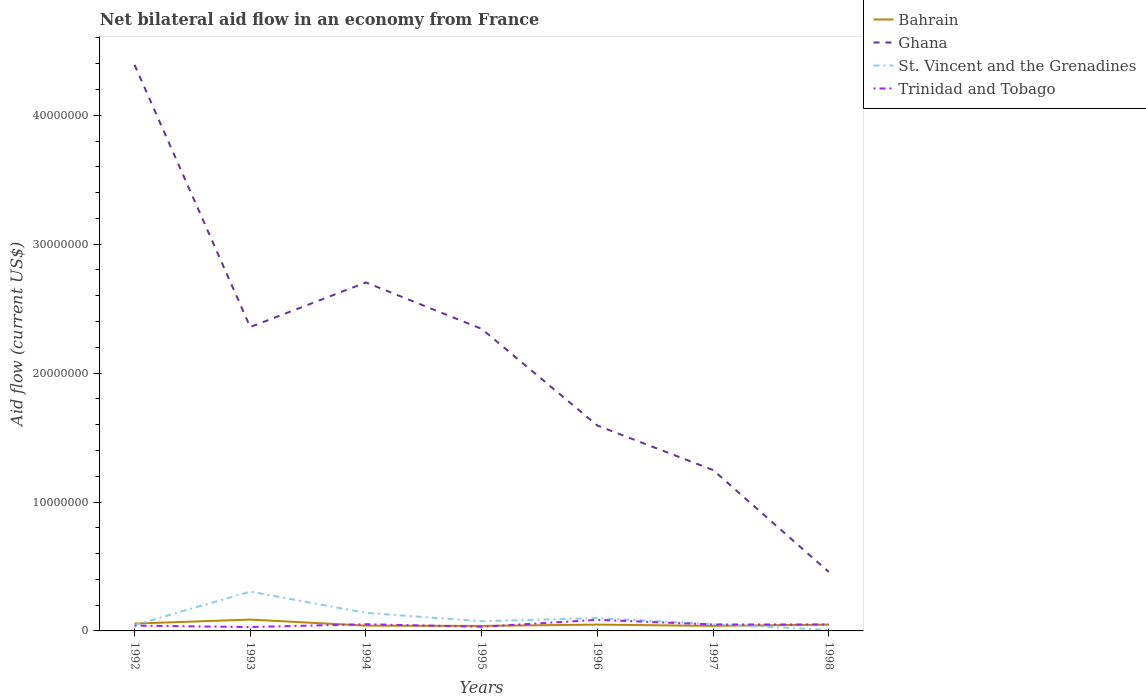How many different coloured lines are there?
Give a very brief answer. 4. Across all years, what is the maximum net bilateral aid flow in Ghana?
Keep it short and to the point. 4.57e+06. What is the total net bilateral aid flow in St. Vincent and the Grenadines in the graph?
Your answer should be compact. 9.20e+05. What is the difference between the highest and the second highest net bilateral aid flow in Trinidad and Tobago?
Your answer should be very brief. 5.60e+05. Is the net bilateral aid flow in St. Vincent and the Grenadines strictly greater than the net bilateral aid flow in Ghana over the years?
Provide a succinct answer. Yes. How many lines are there?
Provide a short and direct response. 4. How many years are there in the graph?
Your answer should be compact. 7. What is the difference between two consecutive major ticks on the Y-axis?
Keep it short and to the point. 1.00e+07. Are the values on the major ticks of Y-axis written in scientific E-notation?
Make the answer very short. No. Does the graph contain grids?
Give a very brief answer. No. Where does the legend appear in the graph?
Your response must be concise. Top right. What is the title of the graph?
Offer a very short reply. Net bilateral aid flow in an economy from France. Does "St. Vincent and the Grenadines" appear as one of the legend labels in the graph?
Your response must be concise. Yes. What is the Aid flow (current US$) of Bahrain in 1992?
Keep it short and to the point. 5.70e+05. What is the Aid flow (current US$) of Ghana in 1992?
Provide a short and direct response. 4.39e+07. What is the Aid flow (current US$) of Bahrain in 1993?
Give a very brief answer. 8.80e+05. What is the Aid flow (current US$) in Ghana in 1993?
Provide a short and direct response. 2.36e+07. What is the Aid flow (current US$) of St. Vincent and the Grenadines in 1993?
Your response must be concise. 3.05e+06. What is the Aid flow (current US$) of Trinidad and Tobago in 1993?
Ensure brevity in your answer.  3.00e+05. What is the Aid flow (current US$) of Bahrain in 1994?
Your response must be concise. 4.10e+05. What is the Aid flow (current US$) in Ghana in 1994?
Provide a short and direct response. 2.70e+07. What is the Aid flow (current US$) of St. Vincent and the Grenadines in 1994?
Keep it short and to the point. 1.40e+06. What is the Aid flow (current US$) in Trinidad and Tobago in 1994?
Your response must be concise. 5.20e+05. What is the Aid flow (current US$) of Ghana in 1995?
Ensure brevity in your answer.  2.34e+07. What is the Aid flow (current US$) in St. Vincent and the Grenadines in 1995?
Keep it short and to the point. 7.50e+05. What is the Aid flow (current US$) of Bahrain in 1996?
Give a very brief answer. 4.90e+05. What is the Aid flow (current US$) of Ghana in 1996?
Offer a very short reply. 1.59e+07. What is the Aid flow (current US$) in Trinidad and Tobago in 1996?
Ensure brevity in your answer.  8.60e+05. What is the Aid flow (current US$) in Bahrain in 1997?
Your response must be concise. 3.90e+05. What is the Aid flow (current US$) of Ghana in 1997?
Keep it short and to the point. 1.25e+07. What is the Aid flow (current US$) of St. Vincent and the Grenadines in 1997?
Offer a terse response. 5.20e+05. What is the Aid flow (current US$) in Bahrain in 1998?
Your response must be concise. 4.90e+05. What is the Aid flow (current US$) of Ghana in 1998?
Keep it short and to the point. 4.57e+06. What is the Aid flow (current US$) of St. Vincent and the Grenadines in 1998?
Your answer should be very brief. 8.00e+04. Across all years, what is the maximum Aid flow (current US$) in Bahrain?
Provide a succinct answer. 8.80e+05. Across all years, what is the maximum Aid flow (current US$) of Ghana?
Give a very brief answer. 4.39e+07. Across all years, what is the maximum Aid flow (current US$) in St. Vincent and the Grenadines?
Give a very brief answer. 3.05e+06. Across all years, what is the maximum Aid flow (current US$) of Trinidad and Tobago?
Ensure brevity in your answer.  8.60e+05. Across all years, what is the minimum Aid flow (current US$) in Ghana?
Offer a terse response. 4.57e+06. Across all years, what is the minimum Aid flow (current US$) in St. Vincent and the Grenadines?
Provide a succinct answer. 8.00e+04. Across all years, what is the minimum Aid flow (current US$) in Trinidad and Tobago?
Ensure brevity in your answer.  3.00e+05. What is the total Aid flow (current US$) of Bahrain in the graph?
Make the answer very short. 3.62e+06. What is the total Aid flow (current US$) in Ghana in the graph?
Provide a succinct answer. 1.51e+08. What is the total Aid flow (current US$) of St. Vincent and the Grenadines in the graph?
Provide a succinct answer. 7.25e+06. What is the total Aid flow (current US$) in Trinidad and Tobago in the graph?
Provide a short and direct response. 3.41e+06. What is the difference between the Aid flow (current US$) of Bahrain in 1992 and that in 1993?
Offer a terse response. -3.10e+05. What is the difference between the Aid flow (current US$) of Ghana in 1992 and that in 1993?
Your response must be concise. 2.03e+07. What is the difference between the Aid flow (current US$) in St. Vincent and the Grenadines in 1992 and that in 1993?
Your response must be concise. -2.60e+06. What is the difference between the Aid flow (current US$) in Trinidad and Tobago in 1992 and that in 1993?
Ensure brevity in your answer.  1.10e+05. What is the difference between the Aid flow (current US$) in Ghana in 1992 and that in 1994?
Keep it short and to the point. 1.69e+07. What is the difference between the Aid flow (current US$) in St. Vincent and the Grenadines in 1992 and that in 1994?
Offer a very short reply. -9.50e+05. What is the difference between the Aid flow (current US$) of Trinidad and Tobago in 1992 and that in 1994?
Offer a very short reply. -1.10e+05. What is the difference between the Aid flow (current US$) of Ghana in 1992 and that in 1995?
Provide a short and direct response. 2.05e+07. What is the difference between the Aid flow (current US$) in Bahrain in 1992 and that in 1996?
Give a very brief answer. 8.00e+04. What is the difference between the Aid flow (current US$) of Ghana in 1992 and that in 1996?
Offer a very short reply. 2.80e+07. What is the difference between the Aid flow (current US$) in St. Vincent and the Grenadines in 1992 and that in 1996?
Offer a terse response. -5.50e+05. What is the difference between the Aid flow (current US$) of Trinidad and Tobago in 1992 and that in 1996?
Your answer should be very brief. -4.50e+05. What is the difference between the Aid flow (current US$) of Ghana in 1992 and that in 1997?
Give a very brief answer. 3.14e+07. What is the difference between the Aid flow (current US$) in St. Vincent and the Grenadines in 1992 and that in 1997?
Give a very brief answer. -7.00e+04. What is the difference between the Aid flow (current US$) in Trinidad and Tobago in 1992 and that in 1997?
Keep it short and to the point. -9.00e+04. What is the difference between the Aid flow (current US$) in Bahrain in 1992 and that in 1998?
Offer a very short reply. 8.00e+04. What is the difference between the Aid flow (current US$) of Ghana in 1992 and that in 1998?
Your response must be concise. 3.93e+07. What is the difference between the Aid flow (current US$) of St. Vincent and the Grenadines in 1992 and that in 1998?
Provide a short and direct response. 3.70e+05. What is the difference between the Aid flow (current US$) in Trinidad and Tobago in 1992 and that in 1998?
Make the answer very short. -9.00e+04. What is the difference between the Aid flow (current US$) of Bahrain in 1993 and that in 1994?
Your answer should be very brief. 4.70e+05. What is the difference between the Aid flow (current US$) in Ghana in 1993 and that in 1994?
Provide a short and direct response. -3.46e+06. What is the difference between the Aid flow (current US$) of St. Vincent and the Grenadines in 1993 and that in 1994?
Give a very brief answer. 1.65e+06. What is the difference between the Aid flow (current US$) in Trinidad and Tobago in 1993 and that in 1994?
Your answer should be very brief. -2.20e+05. What is the difference between the Aid flow (current US$) in Bahrain in 1993 and that in 1995?
Provide a succinct answer. 4.90e+05. What is the difference between the Aid flow (current US$) in Ghana in 1993 and that in 1995?
Make the answer very short. 1.40e+05. What is the difference between the Aid flow (current US$) of St. Vincent and the Grenadines in 1993 and that in 1995?
Keep it short and to the point. 2.30e+06. What is the difference between the Aid flow (current US$) in Ghana in 1993 and that in 1996?
Make the answer very short. 7.64e+06. What is the difference between the Aid flow (current US$) in St. Vincent and the Grenadines in 1993 and that in 1996?
Offer a terse response. 2.05e+06. What is the difference between the Aid flow (current US$) of Trinidad and Tobago in 1993 and that in 1996?
Your response must be concise. -5.60e+05. What is the difference between the Aid flow (current US$) in Bahrain in 1993 and that in 1997?
Make the answer very short. 4.90e+05. What is the difference between the Aid flow (current US$) in Ghana in 1993 and that in 1997?
Provide a short and direct response. 1.11e+07. What is the difference between the Aid flow (current US$) of St. Vincent and the Grenadines in 1993 and that in 1997?
Make the answer very short. 2.53e+06. What is the difference between the Aid flow (current US$) in Trinidad and Tobago in 1993 and that in 1997?
Your response must be concise. -2.00e+05. What is the difference between the Aid flow (current US$) in Bahrain in 1993 and that in 1998?
Your answer should be very brief. 3.90e+05. What is the difference between the Aid flow (current US$) in Ghana in 1993 and that in 1998?
Provide a succinct answer. 1.90e+07. What is the difference between the Aid flow (current US$) in St. Vincent and the Grenadines in 1993 and that in 1998?
Provide a short and direct response. 2.97e+06. What is the difference between the Aid flow (current US$) in Trinidad and Tobago in 1993 and that in 1998?
Make the answer very short. -2.00e+05. What is the difference between the Aid flow (current US$) of Ghana in 1994 and that in 1995?
Your answer should be compact. 3.60e+06. What is the difference between the Aid flow (current US$) in St. Vincent and the Grenadines in 1994 and that in 1995?
Provide a succinct answer. 6.50e+05. What is the difference between the Aid flow (current US$) in Trinidad and Tobago in 1994 and that in 1995?
Ensure brevity in your answer.  2.00e+05. What is the difference between the Aid flow (current US$) in Ghana in 1994 and that in 1996?
Provide a succinct answer. 1.11e+07. What is the difference between the Aid flow (current US$) in St. Vincent and the Grenadines in 1994 and that in 1996?
Make the answer very short. 4.00e+05. What is the difference between the Aid flow (current US$) of Trinidad and Tobago in 1994 and that in 1996?
Keep it short and to the point. -3.40e+05. What is the difference between the Aid flow (current US$) in Ghana in 1994 and that in 1997?
Your answer should be compact. 1.46e+07. What is the difference between the Aid flow (current US$) of St. Vincent and the Grenadines in 1994 and that in 1997?
Keep it short and to the point. 8.80e+05. What is the difference between the Aid flow (current US$) of Trinidad and Tobago in 1994 and that in 1997?
Offer a very short reply. 2.00e+04. What is the difference between the Aid flow (current US$) of Ghana in 1994 and that in 1998?
Your answer should be very brief. 2.25e+07. What is the difference between the Aid flow (current US$) of St. Vincent and the Grenadines in 1994 and that in 1998?
Keep it short and to the point. 1.32e+06. What is the difference between the Aid flow (current US$) in Trinidad and Tobago in 1994 and that in 1998?
Give a very brief answer. 2.00e+04. What is the difference between the Aid flow (current US$) of Ghana in 1995 and that in 1996?
Offer a terse response. 7.50e+06. What is the difference between the Aid flow (current US$) in Trinidad and Tobago in 1995 and that in 1996?
Your answer should be compact. -5.40e+05. What is the difference between the Aid flow (current US$) in Bahrain in 1995 and that in 1997?
Give a very brief answer. 0. What is the difference between the Aid flow (current US$) of Ghana in 1995 and that in 1997?
Provide a succinct answer. 1.10e+07. What is the difference between the Aid flow (current US$) in Trinidad and Tobago in 1995 and that in 1997?
Give a very brief answer. -1.80e+05. What is the difference between the Aid flow (current US$) of Ghana in 1995 and that in 1998?
Make the answer very short. 1.89e+07. What is the difference between the Aid flow (current US$) of St. Vincent and the Grenadines in 1995 and that in 1998?
Your response must be concise. 6.70e+05. What is the difference between the Aid flow (current US$) of Trinidad and Tobago in 1995 and that in 1998?
Offer a very short reply. -1.80e+05. What is the difference between the Aid flow (current US$) in Ghana in 1996 and that in 1997?
Keep it short and to the point. 3.45e+06. What is the difference between the Aid flow (current US$) of Bahrain in 1996 and that in 1998?
Provide a succinct answer. 0. What is the difference between the Aid flow (current US$) of Ghana in 1996 and that in 1998?
Offer a very short reply. 1.14e+07. What is the difference between the Aid flow (current US$) in St. Vincent and the Grenadines in 1996 and that in 1998?
Ensure brevity in your answer.  9.20e+05. What is the difference between the Aid flow (current US$) of Trinidad and Tobago in 1996 and that in 1998?
Make the answer very short. 3.60e+05. What is the difference between the Aid flow (current US$) of Ghana in 1997 and that in 1998?
Offer a very short reply. 7.91e+06. What is the difference between the Aid flow (current US$) in Bahrain in 1992 and the Aid flow (current US$) in Ghana in 1993?
Your answer should be compact. -2.30e+07. What is the difference between the Aid flow (current US$) in Bahrain in 1992 and the Aid flow (current US$) in St. Vincent and the Grenadines in 1993?
Make the answer very short. -2.48e+06. What is the difference between the Aid flow (current US$) in Ghana in 1992 and the Aid flow (current US$) in St. Vincent and the Grenadines in 1993?
Give a very brief answer. 4.09e+07. What is the difference between the Aid flow (current US$) in Ghana in 1992 and the Aid flow (current US$) in Trinidad and Tobago in 1993?
Your answer should be very brief. 4.36e+07. What is the difference between the Aid flow (current US$) in Bahrain in 1992 and the Aid flow (current US$) in Ghana in 1994?
Provide a succinct answer. -2.65e+07. What is the difference between the Aid flow (current US$) of Bahrain in 1992 and the Aid flow (current US$) of St. Vincent and the Grenadines in 1994?
Offer a terse response. -8.30e+05. What is the difference between the Aid flow (current US$) in Ghana in 1992 and the Aid flow (current US$) in St. Vincent and the Grenadines in 1994?
Offer a very short reply. 4.25e+07. What is the difference between the Aid flow (current US$) in Ghana in 1992 and the Aid flow (current US$) in Trinidad and Tobago in 1994?
Your response must be concise. 4.34e+07. What is the difference between the Aid flow (current US$) in St. Vincent and the Grenadines in 1992 and the Aid flow (current US$) in Trinidad and Tobago in 1994?
Your answer should be compact. -7.00e+04. What is the difference between the Aid flow (current US$) of Bahrain in 1992 and the Aid flow (current US$) of Ghana in 1995?
Ensure brevity in your answer.  -2.29e+07. What is the difference between the Aid flow (current US$) in Bahrain in 1992 and the Aid flow (current US$) in St. Vincent and the Grenadines in 1995?
Your answer should be very brief. -1.80e+05. What is the difference between the Aid flow (current US$) in Ghana in 1992 and the Aid flow (current US$) in St. Vincent and the Grenadines in 1995?
Offer a terse response. 4.32e+07. What is the difference between the Aid flow (current US$) of Ghana in 1992 and the Aid flow (current US$) of Trinidad and Tobago in 1995?
Your answer should be very brief. 4.36e+07. What is the difference between the Aid flow (current US$) in Bahrain in 1992 and the Aid flow (current US$) in Ghana in 1996?
Provide a short and direct response. -1.54e+07. What is the difference between the Aid flow (current US$) of Bahrain in 1992 and the Aid flow (current US$) of St. Vincent and the Grenadines in 1996?
Make the answer very short. -4.30e+05. What is the difference between the Aid flow (current US$) in Bahrain in 1992 and the Aid flow (current US$) in Trinidad and Tobago in 1996?
Give a very brief answer. -2.90e+05. What is the difference between the Aid flow (current US$) of Ghana in 1992 and the Aid flow (current US$) of St. Vincent and the Grenadines in 1996?
Offer a terse response. 4.29e+07. What is the difference between the Aid flow (current US$) of Ghana in 1992 and the Aid flow (current US$) of Trinidad and Tobago in 1996?
Your answer should be compact. 4.30e+07. What is the difference between the Aid flow (current US$) in St. Vincent and the Grenadines in 1992 and the Aid flow (current US$) in Trinidad and Tobago in 1996?
Give a very brief answer. -4.10e+05. What is the difference between the Aid flow (current US$) of Bahrain in 1992 and the Aid flow (current US$) of Ghana in 1997?
Your answer should be compact. -1.19e+07. What is the difference between the Aid flow (current US$) of Bahrain in 1992 and the Aid flow (current US$) of St. Vincent and the Grenadines in 1997?
Provide a succinct answer. 5.00e+04. What is the difference between the Aid flow (current US$) in Bahrain in 1992 and the Aid flow (current US$) in Trinidad and Tobago in 1997?
Offer a very short reply. 7.00e+04. What is the difference between the Aid flow (current US$) of Ghana in 1992 and the Aid flow (current US$) of St. Vincent and the Grenadines in 1997?
Offer a terse response. 4.34e+07. What is the difference between the Aid flow (current US$) in Ghana in 1992 and the Aid flow (current US$) in Trinidad and Tobago in 1997?
Offer a terse response. 4.34e+07. What is the difference between the Aid flow (current US$) in Bahrain in 1992 and the Aid flow (current US$) in Trinidad and Tobago in 1998?
Offer a terse response. 7.00e+04. What is the difference between the Aid flow (current US$) in Ghana in 1992 and the Aid flow (current US$) in St. Vincent and the Grenadines in 1998?
Your response must be concise. 4.38e+07. What is the difference between the Aid flow (current US$) of Ghana in 1992 and the Aid flow (current US$) of Trinidad and Tobago in 1998?
Give a very brief answer. 4.34e+07. What is the difference between the Aid flow (current US$) of Bahrain in 1993 and the Aid flow (current US$) of Ghana in 1994?
Make the answer very short. -2.62e+07. What is the difference between the Aid flow (current US$) in Bahrain in 1993 and the Aid flow (current US$) in St. Vincent and the Grenadines in 1994?
Keep it short and to the point. -5.20e+05. What is the difference between the Aid flow (current US$) of Ghana in 1993 and the Aid flow (current US$) of St. Vincent and the Grenadines in 1994?
Your answer should be compact. 2.22e+07. What is the difference between the Aid flow (current US$) in Ghana in 1993 and the Aid flow (current US$) in Trinidad and Tobago in 1994?
Provide a succinct answer. 2.30e+07. What is the difference between the Aid flow (current US$) in St. Vincent and the Grenadines in 1993 and the Aid flow (current US$) in Trinidad and Tobago in 1994?
Provide a short and direct response. 2.53e+06. What is the difference between the Aid flow (current US$) of Bahrain in 1993 and the Aid flow (current US$) of Ghana in 1995?
Ensure brevity in your answer.  -2.26e+07. What is the difference between the Aid flow (current US$) in Bahrain in 1993 and the Aid flow (current US$) in St. Vincent and the Grenadines in 1995?
Your answer should be compact. 1.30e+05. What is the difference between the Aid flow (current US$) in Bahrain in 1993 and the Aid flow (current US$) in Trinidad and Tobago in 1995?
Give a very brief answer. 5.60e+05. What is the difference between the Aid flow (current US$) in Ghana in 1993 and the Aid flow (current US$) in St. Vincent and the Grenadines in 1995?
Provide a succinct answer. 2.28e+07. What is the difference between the Aid flow (current US$) of Ghana in 1993 and the Aid flow (current US$) of Trinidad and Tobago in 1995?
Your answer should be compact. 2.32e+07. What is the difference between the Aid flow (current US$) in St. Vincent and the Grenadines in 1993 and the Aid flow (current US$) in Trinidad and Tobago in 1995?
Make the answer very short. 2.73e+06. What is the difference between the Aid flow (current US$) of Bahrain in 1993 and the Aid flow (current US$) of Ghana in 1996?
Keep it short and to the point. -1.50e+07. What is the difference between the Aid flow (current US$) in Bahrain in 1993 and the Aid flow (current US$) in St. Vincent and the Grenadines in 1996?
Give a very brief answer. -1.20e+05. What is the difference between the Aid flow (current US$) in Bahrain in 1993 and the Aid flow (current US$) in Trinidad and Tobago in 1996?
Ensure brevity in your answer.  2.00e+04. What is the difference between the Aid flow (current US$) of Ghana in 1993 and the Aid flow (current US$) of St. Vincent and the Grenadines in 1996?
Your answer should be very brief. 2.26e+07. What is the difference between the Aid flow (current US$) of Ghana in 1993 and the Aid flow (current US$) of Trinidad and Tobago in 1996?
Your answer should be compact. 2.27e+07. What is the difference between the Aid flow (current US$) in St. Vincent and the Grenadines in 1993 and the Aid flow (current US$) in Trinidad and Tobago in 1996?
Your answer should be compact. 2.19e+06. What is the difference between the Aid flow (current US$) in Bahrain in 1993 and the Aid flow (current US$) in Ghana in 1997?
Make the answer very short. -1.16e+07. What is the difference between the Aid flow (current US$) in Bahrain in 1993 and the Aid flow (current US$) in St. Vincent and the Grenadines in 1997?
Provide a short and direct response. 3.60e+05. What is the difference between the Aid flow (current US$) in Ghana in 1993 and the Aid flow (current US$) in St. Vincent and the Grenadines in 1997?
Keep it short and to the point. 2.30e+07. What is the difference between the Aid flow (current US$) of Ghana in 1993 and the Aid flow (current US$) of Trinidad and Tobago in 1997?
Give a very brief answer. 2.31e+07. What is the difference between the Aid flow (current US$) of St. Vincent and the Grenadines in 1993 and the Aid flow (current US$) of Trinidad and Tobago in 1997?
Offer a very short reply. 2.55e+06. What is the difference between the Aid flow (current US$) in Bahrain in 1993 and the Aid flow (current US$) in Ghana in 1998?
Your response must be concise. -3.69e+06. What is the difference between the Aid flow (current US$) of Ghana in 1993 and the Aid flow (current US$) of St. Vincent and the Grenadines in 1998?
Your answer should be compact. 2.35e+07. What is the difference between the Aid flow (current US$) in Ghana in 1993 and the Aid flow (current US$) in Trinidad and Tobago in 1998?
Your answer should be very brief. 2.31e+07. What is the difference between the Aid flow (current US$) in St. Vincent and the Grenadines in 1993 and the Aid flow (current US$) in Trinidad and Tobago in 1998?
Provide a succinct answer. 2.55e+06. What is the difference between the Aid flow (current US$) of Bahrain in 1994 and the Aid flow (current US$) of Ghana in 1995?
Keep it short and to the point. -2.30e+07. What is the difference between the Aid flow (current US$) in Bahrain in 1994 and the Aid flow (current US$) in Trinidad and Tobago in 1995?
Offer a terse response. 9.00e+04. What is the difference between the Aid flow (current US$) of Ghana in 1994 and the Aid flow (current US$) of St. Vincent and the Grenadines in 1995?
Offer a terse response. 2.63e+07. What is the difference between the Aid flow (current US$) in Ghana in 1994 and the Aid flow (current US$) in Trinidad and Tobago in 1995?
Offer a terse response. 2.67e+07. What is the difference between the Aid flow (current US$) in St. Vincent and the Grenadines in 1994 and the Aid flow (current US$) in Trinidad and Tobago in 1995?
Your answer should be compact. 1.08e+06. What is the difference between the Aid flow (current US$) of Bahrain in 1994 and the Aid flow (current US$) of Ghana in 1996?
Your response must be concise. -1.55e+07. What is the difference between the Aid flow (current US$) in Bahrain in 1994 and the Aid flow (current US$) in St. Vincent and the Grenadines in 1996?
Make the answer very short. -5.90e+05. What is the difference between the Aid flow (current US$) of Bahrain in 1994 and the Aid flow (current US$) of Trinidad and Tobago in 1996?
Offer a very short reply. -4.50e+05. What is the difference between the Aid flow (current US$) of Ghana in 1994 and the Aid flow (current US$) of St. Vincent and the Grenadines in 1996?
Your answer should be very brief. 2.60e+07. What is the difference between the Aid flow (current US$) in Ghana in 1994 and the Aid flow (current US$) in Trinidad and Tobago in 1996?
Offer a terse response. 2.62e+07. What is the difference between the Aid flow (current US$) in St. Vincent and the Grenadines in 1994 and the Aid flow (current US$) in Trinidad and Tobago in 1996?
Provide a succinct answer. 5.40e+05. What is the difference between the Aid flow (current US$) in Bahrain in 1994 and the Aid flow (current US$) in Ghana in 1997?
Your response must be concise. -1.21e+07. What is the difference between the Aid flow (current US$) of Bahrain in 1994 and the Aid flow (current US$) of St. Vincent and the Grenadines in 1997?
Your response must be concise. -1.10e+05. What is the difference between the Aid flow (current US$) in Bahrain in 1994 and the Aid flow (current US$) in Trinidad and Tobago in 1997?
Offer a very short reply. -9.00e+04. What is the difference between the Aid flow (current US$) of Ghana in 1994 and the Aid flow (current US$) of St. Vincent and the Grenadines in 1997?
Provide a short and direct response. 2.65e+07. What is the difference between the Aid flow (current US$) in Ghana in 1994 and the Aid flow (current US$) in Trinidad and Tobago in 1997?
Give a very brief answer. 2.65e+07. What is the difference between the Aid flow (current US$) of Bahrain in 1994 and the Aid flow (current US$) of Ghana in 1998?
Make the answer very short. -4.16e+06. What is the difference between the Aid flow (current US$) in Bahrain in 1994 and the Aid flow (current US$) in Trinidad and Tobago in 1998?
Make the answer very short. -9.00e+04. What is the difference between the Aid flow (current US$) in Ghana in 1994 and the Aid flow (current US$) in St. Vincent and the Grenadines in 1998?
Provide a short and direct response. 2.70e+07. What is the difference between the Aid flow (current US$) of Ghana in 1994 and the Aid flow (current US$) of Trinidad and Tobago in 1998?
Keep it short and to the point. 2.65e+07. What is the difference between the Aid flow (current US$) in Bahrain in 1995 and the Aid flow (current US$) in Ghana in 1996?
Your response must be concise. -1.55e+07. What is the difference between the Aid flow (current US$) in Bahrain in 1995 and the Aid flow (current US$) in St. Vincent and the Grenadines in 1996?
Keep it short and to the point. -6.10e+05. What is the difference between the Aid flow (current US$) in Bahrain in 1995 and the Aid flow (current US$) in Trinidad and Tobago in 1996?
Make the answer very short. -4.70e+05. What is the difference between the Aid flow (current US$) of Ghana in 1995 and the Aid flow (current US$) of St. Vincent and the Grenadines in 1996?
Provide a succinct answer. 2.24e+07. What is the difference between the Aid flow (current US$) in Ghana in 1995 and the Aid flow (current US$) in Trinidad and Tobago in 1996?
Give a very brief answer. 2.26e+07. What is the difference between the Aid flow (current US$) of St. Vincent and the Grenadines in 1995 and the Aid flow (current US$) of Trinidad and Tobago in 1996?
Your response must be concise. -1.10e+05. What is the difference between the Aid flow (current US$) in Bahrain in 1995 and the Aid flow (current US$) in Ghana in 1997?
Give a very brief answer. -1.21e+07. What is the difference between the Aid flow (current US$) in Bahrain in 1995 and the Aid flow (current US$) in Trinidad and Tobago in 1997?
Your response must be concise. -1.10e+05. What is the difference between the Aid flow (current US$) in Ghana in 1995 and the Aid flow (current US$) in St. Vincent and the Grenadines in 1997?
Your answer should be very brief. 2.29e+07. What is the difference between the Aid flow (current US$) in Ghana in 1995 and the Aid flow (current US$) in Trinidad and Tobago in 1997?
Your response must be concise. 2.29e+07. What is the difference between the Aid flow (current US$) of St. Vincent and the Grenadines in 1995 and the Aid flow (current US$) of Trinidad and Tobago in 1997?
Ensure brevity in your answer.  2.50e+05. What is the difference between the Aid flow (current US$) of Bahrain in 1995 and the Aid flow (current US$) of Ghana in 1998?
Give a very brief answer. -4.18e+06. What is the difference between the Aid flow (current US$) in Bahrain in 1995 and the Aid flow (current US$) in St. Vincent and the Grenadines in 1998?
Make the answer very short. 3.10e+05. What is the difference between the Aid flow (current US$) in Ghana in 1995 and the Aid flow (current US$) in St. Vincent and the Grenadines in 1998?
Ensure brevity in your answer.  2.34e+07. What is the difference between the Aid flow (current US$) in Ghana in 1995 and the Aid flow (current US$) in Trinidad and Tobago in 1998?
Ensure brevity in your answer.  2.29e+07. What is the difference between the Aid flow (current US$) in Bahrain in 1996 and the Aid flow (current US$) in Ghana in 1997?
Your response must be concise. -1.20e+07. What is the difference between the Aid flow (current US$) in Bahrain in 1996 and the Aid flow (current US$) in Trinidad and Tobago in 1997?
Your answer should be compact. -10000. What is the difference between the Aid flow (current US$) in Ghana in 1996 and the Aid flow (current US$) in St. Vincent and the Grenadines in 1997?
Ensure brevity in your answer.  1.54e+07. What is the difference between the Aid flow (current US$) in Ghana in 1996 and the Aid flow (current US$) in Trinidad and Tobago in 1997?
Offer a terse response. 1.54e+07. What is the difference between the Aid flow (current US$) in St. Vincent and the Grenadines in 1996 and the Aid flow (current US$) in Trinidad and Tobago in 1997?
Provide a succinct answer. 5.00e+05. What is the difference between the Aid flow (current US$) of Bahrain in 1996 and the Aid flow (current US$) of Ghana in 1998?
Provide a short and direct response. -4.08e+06. What is the difference between the Aid flow (current US$) in Ghana in 1996 and the Aid flow (current US$) in St. Vincent and the Grenadines in 1998?
Make the answer very short. 1.58e+07. What is the difference between the Aid flow (current US$) of Ghana in 1996 and the Aid flow (current US$) of Trinidad and Tobago in 1998?
Provide a succinct answer. 1.54e+07. What is the difference between the Aid flow (current US$) in Bahrain in 1997 and the Aid flow (current US$) in Ghana in 1998?
Your response must be concise. -4.18e+06. What is the difference between the Aid flow (current US$) of Ghana in 1997 and the Aid flow (current US$) of St. Vincent and the Grenadines in 1998?
Ensure brevity in your answer.  1.24e+07. What is the difference between the Aid flow (current US$) of Ghana in 1997 and the Aid flow (current US$) of Trinidad and Tobago in 1998?
Ensure brevity in your answer.  1.20e+07. What is the average Aid flow (current US$) in Bahrain per year?
Keep it short and to the point. 5.17e+05. What is the average Aid flow (current US$) in Ghana per year?
Give a very brief answer. 2.16e+07. What is the average Aid flow (current US$) in St. Vincent and the Grenadines per year?
Provide a short and direct response. 1.04e+06. What is the average Aid flow (current US$) of Trinidad and Tobago per year?
Keep it short and to the point. 4.87e+05. In the year 1992, what is the difference between the Aid flow (current US$) of Bahrain and Aid flow (current US$) of Ghana?
Provide a succinct answer. -4.33e+07. In the year 1992, what is the difference between the Aid flow (current US$) of Bahrain and Aid flow (current US$) of Trinidad and Tobago?
Make the answer very short. 1.60e+05. In the year 1992, what is the difference between the Aid flow (current US$) in Ghana and Aid flow (current US$) in St. Vincent and the Grenadines?
Give a very brief answer. 4.35e+07. In the year 1992, what is the difference between the Aid flow (current US$) of Ghana and Aid flow (current US$) of Trinidad and Tobago?
Offer a terse response. 4.35e+07. In the year 1993, what is the difference between the Aid flow (current US$) in Bahrain and Aid flow (current US$) in Ghana?
Your answer should be very brief. -2.27e+07. In the year 1993, what is the difference between the Aid flow (current US$) of Bahrain and Aid flow (current US$) of St. Vincent and the Grenadines?
Give a very brief answer. -2.17e+06. In the year 1993, what is the difference between the Aid flow (current US$) in Bahrain and Aid flow (current US$) in Trinidad and Tobago?
Offer a very short reply. 5.80e+05. In the year 1993, what is the difference between the Aid flow (current US$) in Ghana and Aid flow (current US$) in St. Vincent and the Grenadines?
Offer a very short reply. 2.05e+07. In the year 1993, what is the difference between the Aid flow (current US$) of Ghana and Aid flow (current US$) of Trinidad and Tobago?
Your answer should be very brief. 2.33e+07. In the year 1993, what is the difference between the Aid flow (current US$) of St. Vincent and the Grenadines and Aid flow (current US$) of Trinidad and Tobago?
Offer a terse response. 2.75e+06. In the year 1994, what is the difference between the Aid flow (current US$) of Bahrain and Aid flow (current US$) of Ghana?
Offer a very short reply. -2.66e+07. In the year 1994, what is the difference between the Aid flow (current US$) in Bahrain and Aid flow (current US$) in St. Vincent and the Grenadines?
Give a very brief answer. -9.90e+05. In the year 1994, what is the difference between the Aid flow (current US$) of Bahrain and Aid flow (current US$) of Trinidad and Tobago?
Offer a terse response. -1.10e+05. In the year 1994, what is the difference between the Aid flow (current US$) of Ghana and Aid flow (current US$) of St. Vincent and the Grenadines?
Make the answer very short. 2.56e+07. In the year 1994, what is the difference between the Aid flow (current US$) of Ghana and Aid flow (current US$) of Trinidad and Tobago?
Your answer should be very brief. 2.65e+07. In the year 1994, what is the difference between the Aid flow (current US$) of St. Vincent and the Grenadines and Aid flow (current US$) of Trinidad and Tobago?
Provide a succinct answer. 8.80e+05. In the year 1995, what is the difference between the Aid flow (current US$) of Bahrain and Aid flow (current US$) of Ghana?
Offer a very short reply. -2.30e+07. In the year 1995, what is the difference between the Aid flow (current US$) of Bahrain and Aid flow (current US$) of St. Vincent and the Grenadines?
Keep it short and to the point. -3.60e+05. In the year 1995, what is the difference between the Aid flow (current US$) of Bahrain and Aid flow (current US$) of Trinidad and Tobago?
Your response must be concise. 7.00e+04. In the year 1995, what is the difference between the Aid flow (current US$) in Ghana and Aid flow (current US$) in St. Vincent and the Grenadines?
Offer a terse response. 2.27e+07. In the year 1995, what is the difference between the Aid flow (current US$) of Ghana and Aid flow (current US$) of Trinidad and Tobago?
Ensure brevity in your answer.  2.31e+07. In the year 1995, what is the difference between the Aid flow (current US$) of St. Vincent and the Grenadines and Aid flow (current US$) of Trinidad and Tobago?
Your answer should be compact. 4.30e+05. In the year 1996, what is the difference between the Aid flow (current US$) of Bahrain and Aid flow (current US$) of Ghana?
Provide a succinct answer. -1.54e+07. In the year 1996, what is the difference between the Aid flow (current US$) in Bahrain and Aid flow (current US$) in St. Vincent and the Grenadines?
Give a very brief answer. -5.10e+05. In the year 1996, what is the difference between the Aid flow (current US$) in Bahrain and Aid flow (current US$) in Trinidad and Tobago?
Your answer should be compact. -3.70e+05. In the year 1996, what is the difference between the Aid flow (current US$) of Ghana and Aid flow (current US$) of St. Vincent and the Grenadines?
Offer a terse response. 1.49e+07. In the year 1996, what is the difference between the Aid flow (current US$) in Ghana and Aid flow (current US$) in Trinidad and Tobago?
Ensure brevity in your answer.  1.51e+07. In the year 1997, what is the difference between the Aid flow (current US$) of Bahrain and Aid flow (current US$) of Ghana?
Your answer should be compact. -1.21e+07. In the year 1997, what is the difference between the Aid flow (current US$) in Bahrain and Aid flow (current US$) in Trinidad and Tobago?
Provide a succinct answer. -1.10e+05. In the year 1997, what is the difference between the Aid flow (current US$) in Ghana and Aid flow (current US$) in St. Vincent and the Grenadines?
Give a very brief answer. 1.20e+07. In the year 1997, what is the difference between the Aid flow (current US$) of Ghana and Aid flow (current US$) of Trinidad and Tobago?
Provide a succinct answer. 1.20e+07. In the year 1997, what is the difference between the Aid flow (current US$) in St. Vincent and the Grenadines and Aid flow (current US$) in Trinidad and Tobago?
Your answer should be very brief. 2.00e+04. In the year 1998, what is the difference between the Aid flow (current US$) in Bahrain and Aid flow (current US$) in Ghana?
Provide a succinct answer. -4.08e+06. In the year 1998, what is the difference between the Aid flow (current US$) of Ghana and Aid flow (current US$) of St. Vincent and the Grenadines?
Offer a terse response. 4.49e+06. In the year 1998, what is the difference between the Aid flow (current US$) in Ghana and Aid flow (current US$) in Trinidad and Tobago?
Offer a very short reply. 4.07e+06. In the year 1998, what is the difference between the Aid flow (current US$) in St. Vincent and the Grenadines and Aid flow (current US$) in Trinidad and Tobago?
Your answer should be very brief. -4.20e+05. What is the ratio of the Aid flow (current US$) of Bahrain in 1992 to that in 1993?
Keep it short and to the point. 0.65. What is the ratio of the Aid flow (current US$) in Ghana in 1992 to that in 1993?
Offer a terse response. 1.86. What is the ratio of the Aid flow (current US$) in St. Vincent and the Grenadines in 1992 to that in 1993?
Provide a succinct answer. 0.15. What is the ratio of the Aid flow (current US$) of Trinidad and Tobago in 1992 to that in 1993?
Provide a short and direct response. 1.37. What is the ratio of the Aid flow (current US$) of Bahrain in 1992 to that in 1994?
Ensure brevity in your answer.  1.39. What is the ratio of the Aid flow (current US$) in Ghana in 1992 to that in 1994?
Give a very brief answer. 1.62. What is the ratio of the Aid flow (current US$) in St. Vincent and the Grenadines in 1992 to that in 1994?
Offer a terse response. 0.32. What is the ratio of the Aid flow (current US$) in Trinidad and Tobago in 1992 to that in 1994?
Offer a very short reply. 0.79. What is the ratio of the Aid flow (current US$) in Bahrain in 1992 to that in 1995?
Give a very brief answer. 1.46. What is the ratio of the Aid flow (current US$) in Ghana in 1992 to that in 1995?
Your response must be concise. 1.87. What is the ratio of the Aid flow (current US$) in St. Vincent and the Grenadines in 1992 to that in 1995?
Give a very brief answer. 0.6. What is the ratio of the Aid flow (current US$) in Trinidad and Tobago in 1992 to that in 1995?
Keep it short and to the point. 1.28. What is the ratio of the Aid flow (current US$) of Bahrain in 1992 to that in 1996?
Your response must be concise. 1.16. What is the ratio of the Aid flow (current US$) of Ghana in 1992 to that in 1996?
Provide a short and direct response. 2.76. What is the ratio of the Aid flow (current US$) of St. Vincent and the Grenadines in 1992 to that in 1996?
Your response must be concise. 0.45. What is the ratio of the Aid flow (current US$) in Trinidad and Tobago in 1992 to that in 1996?
Offer a terse response. 0.48. What is the ratio of the Aid flow (current US$) of Bahrain in 1992 to that in 1997?
Give a very brief answer. 1.46. What is the ratio of the Aid flow (current US$) in Ghana in 1992 to that in 1997?
Your response must be concise. 3.52. What is the ratio of the Aid flow (current US$) of St. Vincent and the Grenadines in 1992 to that in 1997?
Offer a very short reply. 0.87. What is the ratio of the Aid flow (current US$) in Trinidad and Tobago in 1992 to that in 1997?
Offer a very short reply. 0.82. What is the ratio of the Aid flow (current US$) of Bahrain in 1992 to that in 1998?
Offer a very short reply. 1.16. What is the ratio of the Aid flow (current US$) of Ghana in 1992 to that in 1998?
Offer a very short reply. 9.61. What is the ratio of the Aid flow (current US$) in St. Vincent and the Grenadines in 1992 to that in 1998?
Provide a succinct answer. 5.62. What is the ratio of the Aid flow (current US$) of Trinidad and Tobago in 1992 to that in 1998?
Offer a terse response. 0.82. What is the ratio of the Aid flow (current US$) in Bahrain in 1993 to that in 1994?
Provide a succinct answer. 2.15. What is the ratio of the Aid flow (current US$) in Ghana in 1993 to that in 1994?
Provide a short and direct response. 0.87. What is the ratio of the Aid flow (current US$) of St. Vincent and the Grenadines in 1993 to that in 1994?
Ensure brevity in your answer.  2.18. What is the ratio of the Aid flow (current US$) in Trinidad and Tobago in 1993 to that in 1994?
Give a very brief answer. 0.58. What is the ratio of the Aid flow (current US$) of Bahrain in 1993 to that in 1995?
Give a very brief answer. 2.26. What is the ratio of the Aid flow (current US$) in Ghana in 1993 to that in 1995?
Your answer should be very brief. 1.01. What is the ratio of the Aid flow (current US$) of St. Vincent and the Grenadines in 1993 to that in 1995?
Offer a terse response. 4.07. What is the ratio of the Aid flow (current US$) in Bahrain in 1993 to that in 1996?
Make the answer very short. 1.8. What is the ratio of the Aid flow (current US$) in Ghana in 1993 to that in 1996?
Your answer should be compact. 1.48. What is the ratio of the Aid flow (current US$) of St. Vincent and the Grenadines in 1993 to that in 1996?
Keep it short and to the point. 3.05. What is the ratio of the Aid flow (current US$) of Trinidad and Tobago in 1993 to that in 1996?
Offer a terse response. 0.35. What is the ratio of the Aid flow (current US$) in Bahrain in 1993 to that in 1997?
Offer a terse response. 2.26. What is the ratio of the Aid flow (current US$) in Ghana in 1993 to that in 1997?
Provide a short and direct response. 1.89. What is the ratio of the Aid flow (current US$) in St. Vincent and the Grenadines in 1993 to that in 1997?
Your answer should be compact. 5.87. What is the ratio of the Aid flow (current US$) in Trinidad and Tobago in 1993 to that in 1997?
Your answer should be very brief. 0.6. What is the ratio of the Aid flow (current US$) in Bahrain in 1993 to that in 1998?
Your response must be concise. 1.8. What is the ratio of the Aid flow (current US$) in Ghana in 1993 to that in 1998?
Keep it short and to the point. 5.16. What is the ratio of the Aid flow (current US$) of St. Vincent and the Grenadines in 1993 to that in 1998?
Give a very brief answer. 38.12. What is the ratio of the Aid flow (current US$) in Trinidad and Tobago in 1993 to that in 1998?
Provide a succinct answer. 0.6. What is the ratio of the Aid flow (current US$) of Bahrain in 1994 to that in 1995?
Keep it short and to the point. 1.05. What is the ratio of the Aid flow (current US$) of Ghana in 1994 to that in 1995?
Make the answer very short. 1.15. What is the ratio of the Aid flow (current US$) of St. Vincent and the Grenadines in 1994 to that in 1995?
Give a very brief answer. 1.87. What is the ratio of the Aid flow (current US$) in Trinidad and Tobago in 1994 to that in 1995?
Ensure brevity in your answer.  1.62. What is the ratio of the Aid flow (current US$) in Bahrain in 1994 to that in 1996?
Offer a terse response. 0.84. What is the ratio of the Aid flow (current US$) of Ghana in 1994 to that in 1996?
Your answer should be very brief. 1.7. What is the ratio of the Aid flow (current US$) in Trinidad and Tobago in 1994 to that in 1996?
Your answer should be very brief. 0.6. What is the ratio of the Aid flow (current US$) in Bahrain in 1994 to that in 1997?
Make the answer very short. 1.05. What is the ratio of the Aid flow (current US$) of Ghana in 1994 to that in 1997?
Your answer should be very brief. 2.17. What is the ratio of the Aid flow (current US$) of St. Vincent and the Grenadines in 1994 to that in 1997?
Your answer should be compact. 2.69. What is the ratio of the Aid flow (current US$) in Trinidad and Tobago in 1994 to that in 1997?
Your response must be concise. 1.04. What is the ratio of the Aid flow (current US$) of Bahrain in 1994 to that in 1998?
Give a very brief answer. 0.84. What is the ratio of the Aid flow (current US$) of Ghana in 1994 to that in 1998?
Your answer should be very brief. 5.91. What is the ratio of the Aid flow (current US$) in Trinidad and Tobago in 1994 to that in 1998?
Your answer should be compact. 1.04. What is the ratio of the Aid flow (current US$) in Bahrain in 1995 to that in 1996?
Ensure brevity in your answer.  0.8. What is the ratio of the Aid flow (current US$) of Ghana in 1995 to that in 1996?
Offer a very short reply. 1.47. What is the ratio of the Aid flow (current US$) of St. Vincent and the Grenadines in 1995 to that in 1996?
Give a very brief answer. 0.75. What is the ratio of the Aid flow (current US$) of Trinidad and Tobago in 1995 to that in 1996?
Offer a very short reply. 0.37. What is the ratio of the Aid flow (current US$) in Ghana in 1995 to that in 1997?
Your response must be concise. 1.88. What is the ratio of the Aid flow (current US$) in St. Vincent and the Grenadines in 1995 to that in 1997?
Offer a very short reply. 1.44. What is the ratio of the Aid flow (current US$) of Trinidad and Tobago in 1995 to that in 1997?
Ensure brevity in your answer.  0.64. What is the ratio of the Aid flow (current US$) in Bahrain in 1995 to that in 1998?
Ensure brevity in your answer.  0.8. What is the ratio of the Aid flow (current US$) of Ghana in 1995 to that in 1998?
Offer a very short reply. 5.13. What is the ratio of the Aid flow (current US$) in St. Vincent and the Grenadines in 1995 to that in 1998?
Your answer should be compact. 9.38. What is the ratio of the Aid flow (current US$) of Trinidad and Tobago in 1995 to that in 1998?
Offer a very short reply. 0.64. What is the ratio of the Aid flow (current US$) of Bahrain in 1996 to that in 1997?
Offer a very short reply. 1.26. What is the ratio of the Aid flow (current US$) in Ghana in 1996 to that in 1997?
Provide a short and direct response. 1.28. What is the ratio of the Aid flow (current US$) in St. Vincent and the Grenadines in 1996 to that in 1997?
Your response must be concise. 1.92. What is the ratio of the Aid flow (current US$) of Trinidad and Tobago in 1996 to that in 1997?
Give a very brief answer. 1.72. What is the ratio of the Aid flow (current US$) in Ghana in 1996 to that in 1998?
Offer a terse response. 3.49. What is the ratio of the Aid flow (current US$) of Trinidad and Tobago in 1996 to that in 1998?
Give a very brief answer. 1.72. What is the ratio of the Aid flow (current US$) in Bahrain in 1997 to that in 1998?
Keep it short and to the point. 0.8. What is the ratio of the Aid flow (current US$) in Ghana in 1997 to that in 1998?
Your response must be concise. 2.73. What is the ratio of the Aid flow (current US$) of St. Vincent and the Grenadines in 1997 to that in 1998?
Your answer should be very brief. 6.5. What is the ratio of the Aid flow (current US$) of Trinidad and Tobago in 1997 to that in 1998?
Your answer should be very brief. 1. What is the difference between the highest and the second highest Aid flow (current US$) in Bahrain?
Your response must be concise. 3.10e+05. What is the difference between the highest and the second highest Aid flow (current US$) of Ghana?
Your response must be concise. 1.69e+07. What is the difference between the highest and the second highest Aid flow (current US$) in St. Vincent and the Grenadines?
Provide a short and direct response. 1.65e+06. What is the difference between the highest and the second highest Aid flow (current US$) of Trinidad and Tobago?
Offer a very short reply. 3.40e+05. What is the difference between the highest and the lowest Aid flow (current US$) in Ghana?
Your answer should be very brief. 3.93e+07. What is the difference between the highest and the lowest Aid flow (current US$) in St. Vincent and the Grenadines?
Give a very brief answer. 2.97e+06. What is the difference between the highest and the lowest Aid flow (current US$) of Trinidad and Tobago?
Ensure brevity in your answer.  5.60e+05. 